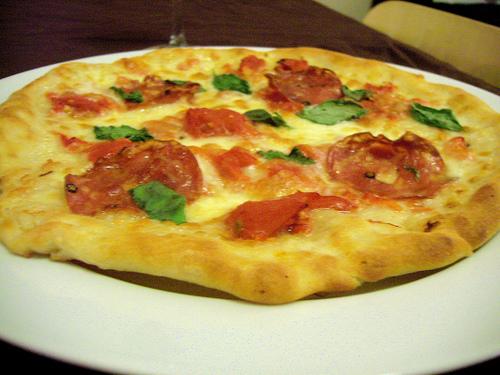Is that the base of a wine glass behind the pizza?
Be succinct. Yes. Is this a veggie pizza?
Answer briefly. No. Is there yellow cheese on the pizza?
Write a very short answer. Yes. 